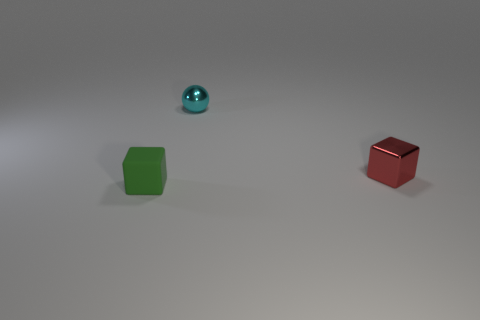Add 3 small red rubber balls. How many objects exist? 6 Subtract all spheres. How many objects are left? 2 Subtract all tiny rubber objects. Subtract all tiny gray metal things. How many objects are left? 2 Add 1 tiny shiny balls. How many tiny shiny balls are left? 2 Add 3 tiny blue metal cylinders. How many tiny blue metal cylinders exist? 3 Subtract 0 green spheres. How many objects are left? 3 